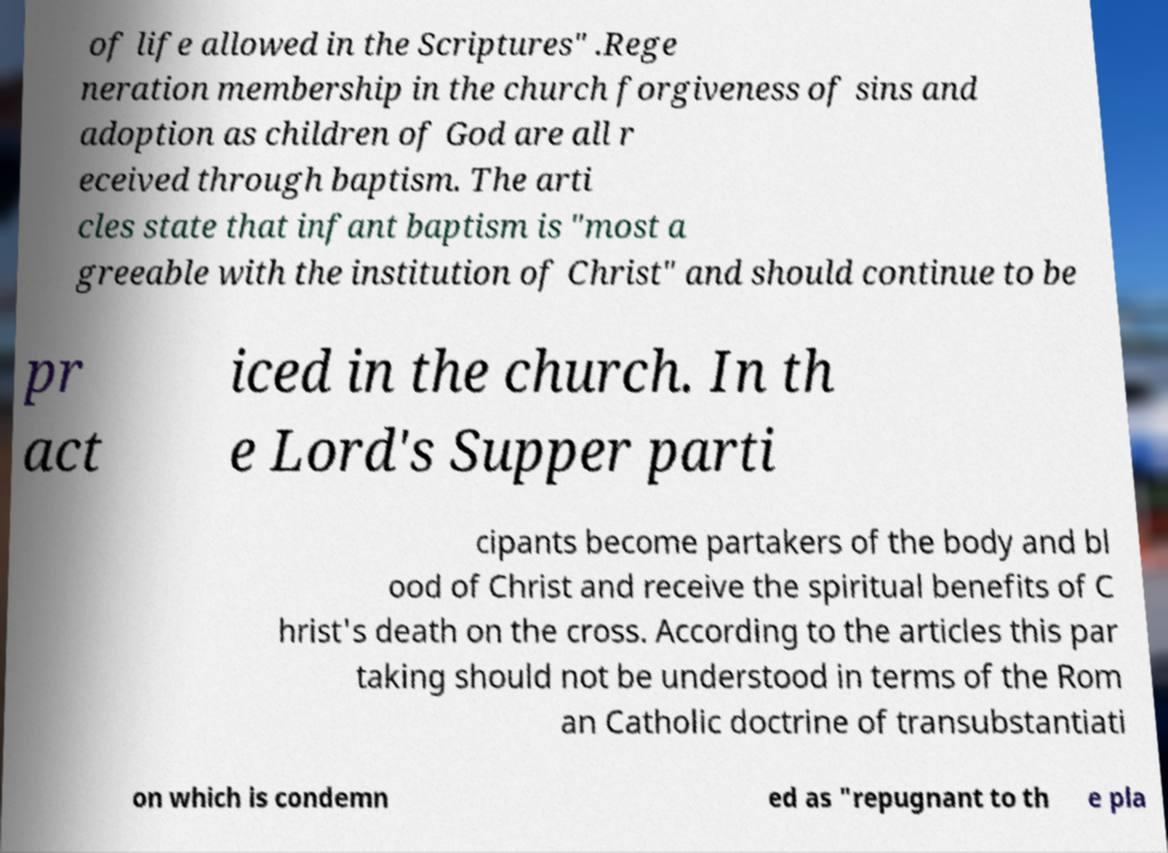Please read and relay the text visible in this image. What does it say? of life allowed in the Scriptures" .Rege neration membership in the church forgiveness of sins and adoption as children of God are all r eceived through baptism. The arti cles state that infant baptism is "most a greeable with the institution of Christ" and should continue to be pr act iced in the church. In th e Lord's Supper parti cipants become partakers of the body and bl ood of Christ and receive the spiritual benefits of C hrist's death on the cross. According to the articles this par taking should not be understood in terms of the Rom an Catholic doctrine of transubstantiati on which is condemn ed as "repugnant to th e pla 